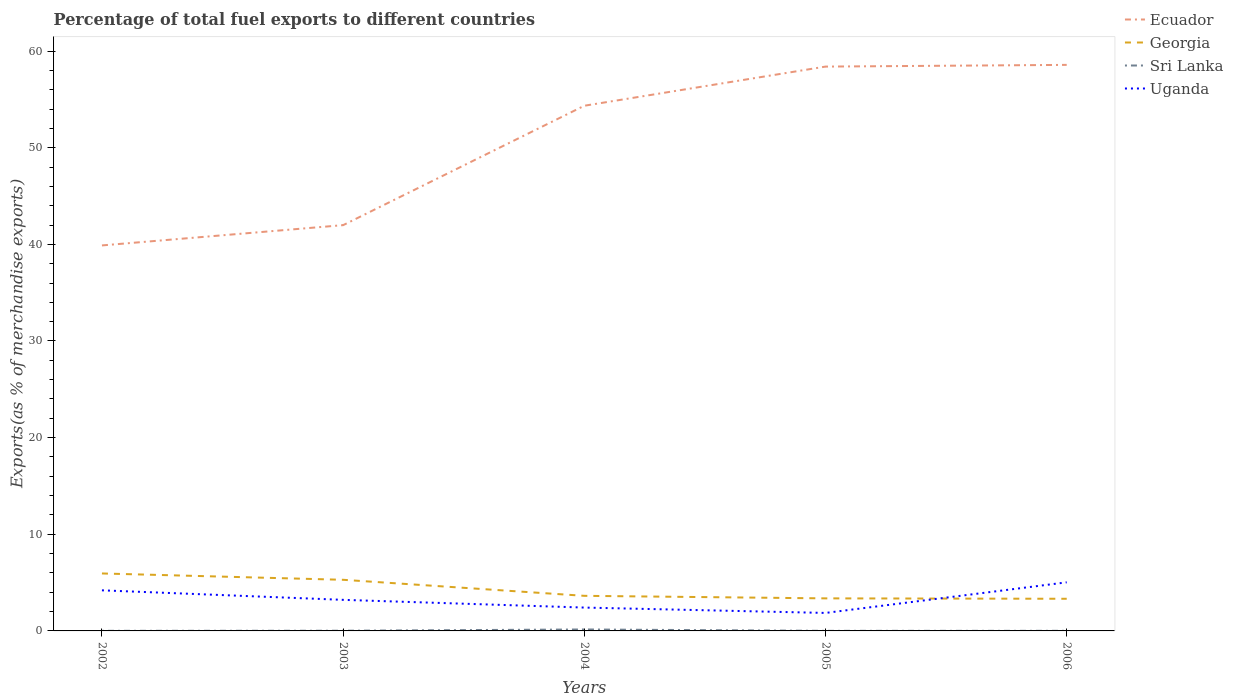How many different coloured lines are there?
Your response must be concise. 4. Is the number of lines equal to the number of legend labels?
Provide a short and direct response. Yes. Across all years, what is the maximum percentage of exports to different countries in Sri Lanka?
Provide a short and direct response. 0.01. In which year was the percentage of exports to different countries in Georgia maximum?
Offer a very short reply. 2006. What is the total percentage of exports to different countries in Uganda in the graph?
Offer a terse response. 1.35. What is the difference between the highest and the second highest percentage of exports to different countries in Ecuador?
Give a very brief answer. 18.68. How many lines are there?
Make the answer very short. 4. What is the difference between two consecutive major ticks on the Y-axis?
Make the answer very short. 10. Does the graph contain any zero values?
Give a very brief answer. No. Where does the legend appear in the graph?
Your answer should be very brief. Top right. What is the title of the graph?
Make the answer very short. Percentage of total fuel exports to different countries. What is the label or title of the Y-axis?
Offer a terse response. Exports(as % of merchandise exports). What is the Exports(as % of merchandise exports) in Ecuador in 2002?
Ensure brevity in your answer.  39.89. What is the Exports(as % of merchandise exports) in Georgia in 2002?
Give a very brief answer. 5.95. What is the Exports(as % of merchandise exports) in Sri Lanka in 2002?
Your answer should be compact. 0.01. What is the Exports(as % of merchandise exports) of Uganda in 2002?
Your answer should be compact. 4.2. What is the Exports(as % of merchandise exports) of Ecuador in 2003?
Ensure brevity in your answer.  41.99. What is the Exports(as % of merchandise exports) of Georgia in 2003?
Your response must be concise. 5.29. What is the Exports(as % of merchandise exports) of Sri Lanka in 2003?
Your answer should be very brief. 0.02. What is the Exports(as % of merchandise exports) in Uganda in 2003?
Offer a terse response. 3.21. What is the Exports(as % of merchandise exports) of Ecuador in 2004?
Provide a short and direct response. 54.34. What is the Exports(as % of merchandise exports) of Georgia in 2004?
Offer a terse response. 3.63. What is the Exports(as % of merchandise exports) in Sri Lanka in 2004?
Keep it short and to the point. 0.15. What is the Exports(as % of merchandise exports) in Uganda in 2004?
Keep it short and to the point. 2.42. What is the Exports(as % of merchandise exports) in Ecuador in 2005?
Give a very brief answer. 58.39. What is the Exports(as % of merchandise exports) in Georgia in 2005?
Give a very brief answer. 3.37. What is the Exports(as % of merchandise exports) of Sri Lanka in 2005?
Ensure brevity in your answer.  0.01. What is the Exports(as % of merchandise exports) of Uganda in 2005?
Offer a terse response. 1.86. What is the Exports(as % of merchandise exports) of Ecuador in 2006?
Make the answer very short. 58.57. What is the Exports(as % of merchandise exports) in Georgia in 2006?
Ensure brevity in your answer.  3.33. What is the Exports(as % of merchandise exports) of Sri Lanka in 2006?
Provide a succinct answer. 0.01. What is the Exports(as % of merchandise exports) of Uganda in 2006?
Your answer should be compact. 5.03. Across all years, what is the maximum Exports(as % of merchandise exports) in Ecuador?
Your response must be concise. 58.57. Across all years, what is the maximum Exports(as % of merchandise exports) of Georgia?
Keep it short and to the point. 5.95. Across all years, what is the maximum Exports(as % of merchandise exports) in Sri Lanka?
Provide a succinct answer. 0.15. Across all years, what is the maximum Exports(as % of merchandise exports) in Uganda?
Give a very brief answer. 5.03. Across all years, what is the minimum Exports(as % of merchandise exports) in Ecuador?
Provide a short and direct response. 39.89. Across all years, what is the minimum Exports(as % of merchandise exports) in Georgia?
Give a very brief answer. 3.33. Across all years, what is the minimum Exports(as % of merchandise exports) of Sri Lanka?
Provide a short and direct response. 0.01. Across all years, what is the minimum Exports(as % of merchandise exports) in Uganda?
Provide a short and direct response. 1.86. What is the total Exports(as % of merchandise exports) in Ecuador in the graph?
Give a very brief answer. 253.18. What is the total Exports(as % of merchandise exports) of Georgia in the graph?
Offer a terse response. 21.56. What is the total Exports(as % of merchandise exports) of Sri Lanka in the graph?
Provide a succinct answer. 0.2. What is the total Exports(as % of merchandise exports) of Uganda in the graph?
Provide a succinct answer. 16.72. What is the difference between the Exports(as % of merchandise exports) of Ecuador in 2002 and that in 2003?
Your answer should be compact. -2.1. What is the difference between the Exports(as % of merchandise exports) of Georgia in 2002 and that in 2003?
Offer a terse response. 0.66. What is the difference between the Exports(as % of merchandise exports) of Sri Lanka in 2002 and that in 2003?
Provide a short and direct response. -0.01. What is the difference between the Exports(as % of merchandise exports) in Uganda in 2002 and that in 2003?
Provide a short and direct response. 0.99. What is the difference between the Exports(as % of merchandise exports) in Ecuador in 2002 and that in 2004?
Ensure brevity in your answer.  -14.45. What is the difference between the Exports(as % of merchandise exports) in Georgia in 2002 and that in 2004?
Offer a terse response. 2.31. What is the difference between the Exports(as % of merchandise exports) in Sri Lanka in 2002 and that in 2004?
Offer a very short reply. -0.14. What is the difference between the Exports(as % of merchandise exports) of Uganda in 2002 and that in 2004?
Make the answer very short. 1.78. What is the difference between the Exports(as % of merchandise exports) in Ecuador in 2002 and that in 2005?
Offer a terse response. -18.5. What is the difference between the Exports(as % of merchandise exports) in Georgia in 2002 and that in 2005?
Ensure brevity in your answer.  2.58. What is the difference between the Exports(as % of merchandise exports) in Sri Lanka in 2002 and that in 2005?
Make the answer very short. 0. What is the difference between the Exports(as % of merchandise exports) in Uganda in 2002 and that in 2005?
Offer a very short reply. 2.34. What is the difference between the Exports(as % of merchandise exports) of Ecuador in 2002 and that in 2006?
Provide a succinct answer. -18.68. What is the difference between the Exports(as % of merchandise exports) in Georgia in 2002 and that in 2006?
Your response must be concise. 2.62. What is the difference between the Exports(as % of merchandise exports) of Sri Lanka in 2002 and that in 2006?
Provide a succinct answer. -0. What is the difference between the Exports(as % of merchandise exports) of Uganda in 2002 and that in 2006?
Keep it short and to the point. -0.83. What is the difference between the Exports(as % of merchandise exports) of Ecuador in 2003 and that in 2004?
Ensure brevity in your answer.  -12.36. What is the difference between the Exports(as % of merchandise exports) in Georgia in 2003 and that in 2004?
Your answer should be very brief. 1.66. What is the difference between the Exports(as % of merchandise exports) in Sri Lanka in 2003 and that in 2004?
Your answer should be compact. -0.13. What is the difference between the Exports(as % of merchandise exports) of Uganda in 2003 and that in 2004?
Keep it short and to the point. 0.8. What is the difference between the Exports(as % of merchandise exports) of Ecuador in 2003 and that in 2005?
Offer a terse response. -16.41. What is the difference between the Exports(as % of merchandise exports) in Georgia in 2003 and that in 2005?
Your response must be concise. 1.92. What is the difference between the Exports(as % of merchandise exports) of Sri Lanka in 2003 and that in 2005?
Ensure brevity in your answer.  0.01. What is the difference between the Exports(as % of merchandise exports) in Uganda in 2003 and that in 2005?
Ensure brevity in your answer.  1.35. What is the difference between the Exports(as % of merchandise exports) in Ecuador in 2003 and that in 2006?
Provide a succinct answer. -16.58. What is the difference between the Exports(as % of merchandise exports) of Georgia in 2003 and that in 2006?
Keep it short and to the point. 1.96. What is the difference between the Exports(as % of merchandise exports) in Sri Lanka in 2003 and that in 2006?
Provide a succinct answer. 0.01. What is the difference between the Exports(as % of merchandise exports) of Uganda in 2003 and that in 2006?
Your answer should be very brief. -1.81. What is the difference between the Exports(as % of merchandise exports) in Ecuador in 2004 and that in 2005?
Offer a terse response. -4.05. What is the difference between the Exports(as % of merchandise exports) in Georgia in 2004 and that in 2005?
Offer a terse response. 0.26. What is the difference between the Exports(as % of merchandise exports) of Sri Lanka in 2004 and that in 2005?
Offer a terse response. 0.14. What is the difference between the Exports(as % of merchandise exports) in Uganda in 2004 and that in 2005?
Ensure brevity in your answer.  0.56. What is the difference between the Exports(as % of merchandise exports) in Ecuador in 2004 and that in 2006?
Offer a terse response. -4.23. What is the difference between the Exports(as % of merchandise exports) in Georgia in 2004 and that in 2006?
Your answer should be very brief. 0.3. What is the difference between the Exports(as % of merchandise exports) of Sri Lanka in 2004 and that in 2006?
Make the answer very short. 0.14. What is the difference between the Exports(as % of merchandise exports) of Uganda in 2004 and that in 2006?
Ensure brevity in your answer.  -2.61. What is the difference between the Exports(as % of merchandise exports) of Ecuador in 2005 and that in 2006?
Your answer should be compact. -0.18. What is the difference between the Exports(as % of merchandise exports) in Georgia in 2005 and that in 2006?
Keep it short and to the point. 0.04. What is the difference between the Exports(as % of merchandise exports) in Sri Lanka in 2005 and that in 2006?
Your answer should be very brief. -0. What is the difference between the Exports(as % of merchandise exports) in Uganda in 2005 and that in 2006?
Your answer should be compact. -3.17. What is the difference between the Exports(as % of merchandise exports) in Ecuador in 2002 and the Exports(as % of merchandise exports) in Georgia in 2003?
Provide a short and direct response. 34.6. What is the difference between the Exports(as % of merchandise exports) of Ecuador in 2002 and the Exports(as % of merchandise exports) of Sri Lanka in 2003?
Make the answer very short. 39.87. What is the difference between the Exports(as % of merchandise exports) of Ecuador in 2002 and the Exports(as % of merchandise exports) of Uganda in 2003?
Offer a very short reply. 36.67. What is the difference between the Exports(as % of merchandise exports) of Georgia in 2002 and the Exports(as % of merchandise exports) of Sri Lanka in 2003?
Make the answer very short. 5.93. What is the difference between the Exports(as % of merchandise exports) in Georgia in 2002 and the Exports(as % of merchandise exports) in Uganda in 2003?
Provide a short and direct response. 2.73. What is the difference between the Exports(as % of merchandise exports) in Sri Lanka in 2002 and the Exports(as % of merchandise exports) in Uganda in 2003?
Provide a succinct answer. -3.2. What is the difference between the Exports(as % of merchandise exports) in Ecuador in 2002 and the Exports(as % of merchandise exports) in Georgia in 2004?
Make the answer very short. 36.26. What is the difference between the Exports(as % of merchandise exports) of Ecuador in 2002 and the Exports(as % of merchandise exports) of Sri Lanka in 2004?
Give a very brief answer. 39.74. What is the difference between the Exports(as % of merchandise exports) of Ecuador in 2002 and the Exports(as % of merchandise exports) of Uganda in 2004?
Your answer should be very brief. 37.47. What is the difference between the Exports(as % of merchandise exports) in Georgia in 2002 and the Exports(as % of merchandise exports) in Sri Lanka in 2004?
Your response must be concise. 5.79. What is the difference between the Exports(as % of merchandise exports) of Georgia in 2002 and the Exports(as % of merchandise exports) of Uganda in 2004?
Give a very brief answer. 3.53. What is the difference between the Exports(as % of merchandise exports) in Sri Lanka in 2002 and the Exports(as % of merchandise exports) in Uganda in 2004?
Offer a terse response. -2.41. What is the difference between the Exports(as % of merchandise exports) in Ecuador in 2002 and the Exports(as % of merchandise exports) in Georgia in 2005?
Give a very brief answer. 36.52. What is the difference between the Exports(as % of merchandise exports) of Ecuador in 2002 and the Exports(as % of merchandise exports) of Sri Lanka in 2005?
Offer a very short reply. 39.88. What is the difference between the Exports(as % of merchandise exports) of Ecuador in 2002 and the Exports(as % of merchandise exports) of Uganda in 2005?
Provide a short and direct response. 38.03. What is the difference between the Exports(as % of merchandise exports) of Georgia in 2002 and the Exports(as % of merchandise exports) of Sri Lanka in 2005?
Provide a short and direct response. 5.94. What is the difference between the Exports(as % of merchandise exports) of Georgia in 2002 and the Exports(as % of merchandise exports) of Uganda in 2005?
Make the answer very short. 4.08. What is the difference between the Exports(as % of merchandise exports) of Sri Lanka in 2002 and the Exports(as % of merchandise exports) of Uganda in 2005?
Offer a terse response. -1.85. What is the difference between the Exports(as % of merchandise exports) in Ecuador in 2002 and the Exports(as % of merchandise exports) in Georgia in 2006?
Provide a short and direct response. 36.56. What is the difference between the Exports(as % of merchandise exports) in Ecuador in 2002 and the Exports(as % of merchandise exports) in Sri Lanka in 2006?
Your answer should be very brief. 39.88. What is the difference between the Exports(as % of merchandise exports) in Ecuador in 2002 and the Exports(as % of merchandise exports) in Uganda in 2006?
Your answer should be compact. 34.86. What is the difference between the Exports(as % of merchandise exports) of Georgia in 2002 and the Exports(as % of merchandise exports) of Sri Lanka in 2006?
Ensure brevity in your answer.  5.93. What is the difference between the Exports(as % of merchandise exports) in Georgia in 2002 and the Exports(as % of merchandise exports) in Uganda in 2006?
Ensure brevity in your answer.  0.92. What is the difference between the Exports(as % of merchandise exports) in Sri Lanka in 2002 and the Exports(as % of merchandise exports) in Uganda in 2006?
Offer a very short reply. -5.02. What is the difference between the Exports(as % of merchandise exports) in Ecuador in 2003 and the Exports(as % of merchandise exports) in Georgia in 2004?
Your response must be concise. 38.36. What is the difference between the Exports(as % of merchandise exports) in Ecuador in 2003 and the Exports(as % of merchandise exports) in Sri Lanka in 2004?
Offer a very short reply. 41.84. What is the difference between the Exports(as % of merchandise exports) of Ecuador in 2003 and the Exports(as % of merchandise exports) of Uganda in 2004?
Your answer should be compact. 39.57. What is the difference between the Exports(as % of merchandise exports) in Georgia in 2003 and the Exports(as % of merchandise exports) in Sri Lanka in 2004?
Keep it short and to the point. 5.14. What is the difference between the Exports(as % of merchandise exports) of Georgia in 2003 and the Exports(as % of merchandise exports) of Uganda in 2004?
Provide a succinct answer. 2.87. What is the difference between the Exports(as % of merchandise exports) in Sri Lanka in 2003 and the Exports(as % of merchandise exports) in Uganda in 2004?
Ensure brevity in your answer.  -2.4. What is the difference between the Exports(as % of merchandise exports) of Ecuador in 2003 and the Exports(as % of merchandise exports) of Georgia in 2005?
Your answer should be compact. 38.62. What is the difference between the Exports(as % of merchandise exports) of Ecuador in 2003 and the Exports(as % of merchandise exports) of Sri Lanka in 2005?
Give a very brief answer. 41.98. What is the difference between the Exports(as % of merchandise exports) in Ecuador in 2003 and the Exports(as % of merchandise exports) in Uganda in 2005?
Your answer should be compact. 40.13. What is the difference between the Exports(as % of merchandise exports) of Georgia in 2003 and the Exports(as % of merchandise exports) of Sri Lanka in 2005?
Make the answer very short. 5.28. What is the difference between the Exports(as % of merchandise exports) in Georgia in 2003 and the Exports(as % of merchandise exports) in Uganda in 2005?
Make the answer very short. 3.43. What is the difference between the Exports(as % of merchandise exports) in Sri Lanka in 2003 and the Exports(as % of merchandise exports) in Uganda in 2005?
Your answer should be compact. -1.84. What is the difference between the Exports(as % of merchandise exports) in Ecuador in 2003 and the Exports(as % of merchandise exports) in Georgia in 2006?
Your response must be concise. 38.66. What is the difference between the Exports(as % of merchandise exports) in Ecuador in 2003 and the Exports(as % of merchandise exports) in Sri Lanka in 2006?
Make the answer very short. 41.98. What is the difference between the Exports(as % of merchandise exports) in Ecuador in 2003 and the Exports(as % of merchandise exports) in Uganda in 2006?
Ensure brevity in your answer.  36.96. What is the difference between the Exports(as % of merchandise exports) in Georgia in 2003 and the Exports(as % of merchandise exports) in Sri Lanka in 2006?
Give a very brief answer. 5.28. What is the difference between the Exports(as % of merchandise exports) of Georgia in 2003 and the Exports(as % of merchandise exports) of Uganda in 2006?
Your response must be concise. 0.26. What is the difference between the Exports(as % of merchandise exports) in Sri Lanka in 2003 and the Exports(as % of merchandise exports) in Uganda in 2006?
Your answer should be very brief. -5.01. What is the difference between the Exports(as % of merchandise exports) of Ecuador in 2004 and the Exports(as % of merchandise exports) of Georgia in 2005?
Keep it short and to the point. 50.97. What is the difference between the Exports(as % of merchandise exports) in Ecuador in 2004 and the Exports(as % of merchandise exports) in Sri Lanka in 2005?
Provide a succinct answer. 54.33. What is the difference between the Exports(as % of merchandise exports) in Ecuador in 2004 and the Exports(as % of merchandise exports) in Uganda in 2005?
Give a very brief answer. 52.48. What is the difference between the Exports(as % of merchandise exports) of Georgia in 2004 and the Exports(as % of merchandise exports) of Sri Lanka in 2005?
Provide a short and direct response. 3.62. What is the difference between the Exports(as % of merchandise exports) of Georgia in 2004 and the Exports(as % of merchandise exports) of Uganda in 2005?
Your answer should be compact. 1.77. What is the difference between the Exports(as % of merchandise exports) of Sri Lanka in 2004 and the Exports(as % of merchandise exports) of Uganda in 2005?
Offer a very short reply. -1.71. What is the difference between the Exports(as % of merchandise exports) of Ecuador in 2004 and the Exports(as % of merchandise exports) of Georgia in 2006?
Make the answer very short. 51.02. What is the difference between the Exports(as % of merchandise exports) in Ecuador in 2004 and the Exports(as % of merchandise exports) in Sri Lanka in 2006?
Your answer should be very brief. 54.33. What is the difference between the Exports(as % of merchandise exports) of Ecuador in 2004 and the Exports(as % of merchandise exports) of Uganda in 2006?
Offer a terse response. 49.31. What is the difference between the Exports(as % of merchandise exports) of Georgia in 2004 and the Exports(as % of merchandise exports) of Sri Lanka in 2006?
Your answer should be compact. 3.62. What is the difference between the Exports(as % of merchandise exports) in Georgia in 2004 and the Exports(as % of merchandise exports) in Uganda in 2006?
Your answer should be very brief. -1.4. What is the difference between the Exports(as % of merchandise exports) of Sri Lanka in 2004 and the Exports(as % of merchandise exports) of Uganda in 2006?
Provide a succinct answer. -4.88. What is the difference between the Exports(as % of merchandise exports) of Ecuador in 2005 and the Exports(as % of merchandise exports) of Georgia in 2006?
Your answer should be very brief. 55.07. What is the difference between the Exports(as % of merchandise exports) of Ecuador in 2005 and the Exports(as % of merchandise exports) of Sri Lanka in 2006?
Your response must be concise. 58.38. What is the difference between the Exports(as % of merchandise exports) in Ecuador in 2005 and the Exports(as % of merchandise exports) in Uganda in 2006?
Give a very brief answer. 53.36. What is the difference between the Exports(as % of merchandise exports) of Georgia in 2005 and the Exports(as % of merchandise exports) of Sri Lanka in 2006?
Keep it short and to the point. 3.36. What is the difference between the Exports(as % of merchandise exports) of Georgia in 2005 and the Exports(as % of merchandise exports) of Uganda in 2006?
Your answer should be compact. -1.66. What is the difference between the Exports(as % of merchandise exports) in Sri Lanka in 2005 and the Exports(as % of merchandise exports) in Uganda in 2006?
Keep it short and to the point. -5.02. What is the average Exports(as % of merchandise exports) of Ecuador per year?
Offer a very short reply. 50.64. What is the average Exports(as % of merchandise exports) in Georgia per year?
Ensure brevity in your answer.  4.31. What is the average Exports(as % of merchandise exports) in Sri Lanka per year?
Provide a succinct answer. 0.04. What is the average Exports(as % of merchandise exports) in Uganda per year?
Provide a succinct answer. 3.34. In the year 2002, what is the difference between the Exports(as % of merchandise exports) of Ecuador and Exports(as % of merchandise exports) of Georgia?
Give a very brief answer. 33.94. In the year 2002, what is the difference between the Exports(as % of merchandise exports) of Ecuador and Exports(as % of merchandise exports) of Sri Lanka?
Your answer should be very brief. 39.88. In the year 2002, what is the difference between the Exports(as % of merchandise exports) of Ecuador and Exports(as % of merchandise exports) of Uganda?
Your response must be concise. 35.69. In the year 2002, what is the difference between the Exports(as % of merchandise exports) in Georgia and Exports(as % of merchandise exports) in Sri Lanka?
Your answer should be compact. 5.94. In the year 2002, what is the difference between the Exports(as % of merchandise exports) in Georgia and Exports(as % of merchandise exports) in Uganda?
Make the answer very short. 1.75. In the year 2002, what is the difference between the Exports(as % of merchandise exports) of Sri Lanka and Exports(as % of merchandise exports) of Uganda?
Provide a short and direct response. -4.19. In the year 2003, what is the difference between the Exports(as % of merchandise exports) in Ecuador and Exports(as % of merchandise exports) in Georgia?
Your response must be concise. 36.7. In the year 2003, what is the difference between the Exports(as % of merchandise exports) in Ecuador and Exports(as % of merchandise exports) in Sri Lanka?
Make the answer very short. 41.97. In the year 2003, what is the difference between the Exports(as % of merchandise exports) of Ecuador and Exports(as % of merchandise exports) of Uganda?
Your answer should be compact. 38.77. In the year 2003, what is the difference between the Exports(as % of merchandise exports) in Georgia and Exports(as % of merchandise exports) in Sri Lanka?
Provide a short and direct response. 5.27. In the year 2003, what is the difference between the Exports(as % of merchandise exports) of Georgia and Exports(as % of merchandise exports) of Uganda?
Keep it short and to the point. 2.08. In the year 2003, what is the difference between the Exports(as % of merchandise exports) of Sri Lanka and Exports(as % of merchandise exports) of Uganda?
Provide a succinct answer. -3.2. In the year 2004, what is the difference between the Exports(as % of merchandise exports) of Ecuador and Exports(as % of merchandise exports) of Georgia?
Provide a short and direct response. 50.71. In the year 2004, what is the difference between the Exports(as % of merchandise exports) in Ecuador and Exports(as % of merchandise exports) in Sri Lanka?
Give a very brief answer. 54.19. In the year 2004, what is the difference between the Exports(as % of merchandise exports) of Ecuador and Exports(as % of merchandise exports) of Uganda?
Your answer should be very brief. 51.93. In the year 2004, what is the difference between the Exports(as % of merchandise exports) of Georgia and Exports(as % of merchandise exports) of Sri Lanka?
Ensure brevity in your answer.  3.48. In the year 2004, what is the difference between the Exports(as % of merchandise exports) of Georgia and Exports(as % of merchandise exports) of Uganda?
Offer a very short reply. 1.21. In the year 2004, what is the difference between the Exports(as % of merchandise exports) in Sri Lanka and Exports(as % of merchandise exports) in Uganda?
Give a very brief answer. -2.27. In the year 2005, what is the difference between the Exports(as % of merchandise exports) in Ecuador and Exports(as % of merchandise exports) in Georgia?
Keep it short and to the point. 55.02. In the year 2005, what is the difference between the Exports(as % of merchandise exports) of Ecuador and Exports(as % of merchandise exports) of Sri Lanka?
Give a very brief answer. 58.38. In the year 2005, what is the difference between the Exports(as % of merchandise exports) of Ecuador and Exports(as % of merchandise exports) of Uganda?
Offer a very short reply. 56.53. In the year 2005, what is the difference between the Exports(as % of merchandise exports) in Georgia and Exports(as % of merchandise exports) in Sri Lanka?
Your response must be concise. 3.36. In the year 2005, what is the difference between the Exports(as % of merchandise exports) in Georgia and Exports(as % of merchandise exports) in Uganda?
Provide a short and direct response. 1.51. In the year 2005, what is the difference between the Exports(as % of merchandise exports) in Sri Lanka and Exports(as % of merchandise exports) in Uganda?
Offer a very short reply. -1.85. In the year 2006, what is the difference between the Exports(as % of merchandise exports) of Ecuador and Exports(as % of merchandise exports) of Georgia?
Ensure brevity in your answer.  55.24. In the year 2006, what is the difference between the Exports(as % of merchandise exports) in Ecuador and Exports(as % of merchandise exports) in Sri Lanka?
Provide a succinct answer. 58.56. In the year 2006, what is the difference between the Exports(as % of merchandise exports) of Ecuador and Exports(as % of merchandise exports) of Uganda?
Provide a short and direct response. 53.54. In the year 2006, what is the difference between the Exports(as % of merchandise exports) in Georgia and Exports(as % of merchandise exports) in Sri Lanka?
Provide a succinct answer. 3.32. In the year 2006, what is the difference between the Exports(as % of merchandise exports) in Georgia and Exports(as % of merchandise exports) in Uganda?
Your answer should be very brief. -1.7. In the year 2006, what is the difference between the Exports(as % of merchandise exports) of Sri Lanka and Exports(as % of merchandise exports) of Uganda?
Offer a terse response. -5.02. What is the ratio of the Exports(as % of merchandise exports) in Ecuador in 2002 to that in 2003?
Give a very brief answer. 0.95. What is the ratio of the Exports(as % of merchandise exports) of Georgia in 2002 to that in 2003?
Your answer should be very brief. 1.12. What is the ratio of the Exports(as % of merchandise exports) of Sri Lanka in 2002 to that in 2003?
Your answer should be compact. 0.52. What is the ratio of the Exports(as % of merchandise exports) in Uganda in 2002 to that in 2003?
Offer a very short reply. 1.31. What is the ratio of the Exports(as % of merchandise exports) in Ecuador in 2002 to that in 2004?
Provide a short and direct response. 0.73. What is the ratio of the Exports(as % of merchandise exports) of Georgia in 2002 to that in 2004?
Give a very brief answer. 1.64. What is the ratio of the Exports(as % of merchandise exports) in Sri Lanka in 2002 to that in 2004?
Provide a succinct answer. 0.07. What is the ratio of the Exports(as % of merchandise exports) in Uganda in 2002 to that in 2004?
Provide a short and direct response. 1.74. What is the ratio of the Exports(as % of merchandise exports) in Ecuador in 2002 to that in 2005?
Your answer should be compact. 0.68. What is the ratio of the Exports(as % of merchandise exports) in Georgia in 2002 to that in 2005?
Make the answer very short. 1.77. What is the ratio of the Exports(as % of merchandise exports) in Sri Lanka in 2002 to that in 2005?
Your answer should be compact. 1.17. What is the ratio of the Exports(as % of merchandise exports) in Uganda in 2002 to that in 2005?
Offer a very short reply. 2.26. What is the ratio of the Exports(as % of merchandise exports) in Ecuador in 2002 to that in 2006?
Your answer should be very brief. 0.68. What is the ratio of the Exports(as % of merchandise exports) in Georgia in 2002 to that in 2006?
Keep it short and to the point. 1.79. What is the ratio of the Exports(as % of merchandise exports) in Sri Lanka in 2002 to that in 2006?
Give a very brief answer. 0.93. What is the ratio of the Exports(as % of merchandise exports) of Uganda in 2002 to that in 2006?
Give a very brief answer. 0.84. What is the ratio of the Exports(as % of merchandise exports) of Ecuador in 2003 to that in 2004?
Ensure brevity in your answer.  0.77. What is the ratio of the Exports(as % of merchandise exports) of Georgia in 2003 to that in 2004?
Make the answer very short. 1.46. What is the ratio of the Exports(as % of merchandise exports) in Sri Lanka in 2003 to that in 2004?
Provide a succinct answer. 0.13. What is the ratio of the Exports(as % of merchandise exports) of Uganda in 2003 to that in 2004?
Your answer should be compact. 1.33. What is the ratio of the Exports(as % of merchandise exports) in Ecuador in 2003 to that in 2005?
Make the answer very short. 0.72. What is the ratio of the Exports(as % of merchandise exports) in Georgia in 2003 to that in 2005?
Give a very brief answer. 1.57. What is the ratio of the Exports(as % of merchandise exports) in Sri Lanka in 2003 to that in 2005?
Offer a very short reply. 2.24. What is the ratio of the Exports(as % of merchandise exports) in Uganda in 2003 to that in 2005?
Your answer should be very brief. 1.73. What is the ratio of the Exports(as % of merchandise exports) in Ecuador in 2003 to that in 2006?
Keep it short and to the point. 0.72. What is the ratio of the Exports(as % of merchandise exports) in Georgia in 2003 to that in 2006?
Give a very brief answer. 1.59. What is the ratio of the Exports(as % of merchandise exports) of Sri Lanka in 2003 to that in 2006?
Your answer should be compact. 1.79. What is the ratio of the Exports(as % of merchandise exports) of Uganda in 2003 to that in 2006?
Keep it short and to the point. 0.64. What is the ratio of the Exports(as % of merchandise exports) of Ecuador in 2004 to that in 2005?
Make the answer very short. 0.93. What is the ratio of the Exports(as % of merchandise exports) in Georgia in 2004 to that in 2005?
Offer a terse response. 1.08. What is the ratio of the Exports(as % of merchandise exports) in Sri Lanka in 2004 to that in 2005?
Offer a terse response. 17.45. What is the ratio of the Exports(as % of merchandise exports) of Uganda in 2004 to that in 2005?
Provide a short and direct response. 1.3. What is the ratio of the Exports(as % of merchandise exports) in Ecuador in 2004 to that in 2006?
Offer a terse response. 0.93. What is the ratio of the Exports(as % of merchandise exports) of Georgia in 2004 to that in 2006?
Your response must be concise. 1.09. What is the ratio of the Exports(as % of merchandise exports) of Sri Lanka in 2004 to that in 2006?
Provide a short and direct response. 13.97. What is the ratio of the Exports(as % of merchandise exports) in Uganda in 2004 to that in 2006?
Your response must be concise. 0.48. What is the ratio of the Exports(as % of merchandise exports) in Ecuador in 2005 to that in 2006?
Offer a very short reply. 1. What is the ratio of the Exports(as % of merchandise exports) in Georgia in 2005 to that in 2006?
Your answer should be very brief. 1.01. What is the ratio of the Exports(as % of merchandise exports) of Sri Lanka in 2005 to that in 2006?
Keep it short and to the point. 0.8. What is the ratio of the Exports(as % of merchandise exports) of Uganda in 2005 to that in 2006?
Your answer should be very brief. 0.37. What is the difference between the highest and the second highest Exports(as % of merchandise exports) in Ecuador?
Offer a terse response. 0.18. What is the difference between the highest and the second highest Exports(as % of merchandise exports) in Georgia?
Offer a very short reply. 0.66. What is the difference between the highest and the second highest Exports(as % of merchandise exports) in Sri Lanka?
Offer a terse response. 0.13. What is the difference between the highest and the second highest Exports(as % of merchandise exports) in Uganda?
Ensure brevity in your answer.  0.83. What is the difference between the highest and the lowest Exports(as % of merchandise exports) in Ecuador?
Your answer should be very brief. 18.68. What is the difference between the highest and the lowest Exports(as % of merchandise exports) in Georgia?
Give a very brief answer. 2.62. What is the difference between the highest and the lowest Exports(as % of merchandise exports) of Sri Lanka?
Your response must be concise. 0.14. What is the difference between the highest and the lowest Exports(as % of merchandise exports) of Uganda?
Give a very brief answer. 3.17. 